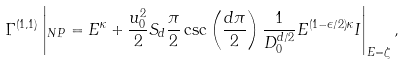Convert formula to latex. <formula><loc_0><loc_0><loc_500><loc_500>\Gamma ^ { ( 1 , 1 ) } \left | _ { N P } = E ^ { \kappa } + \frac { u _ { 0 } ^ { 2 } } { 2 } S _ { d } \frac { \pi } { 2 } \csc \left ( \frac { d \pi } { 2 } \right ) \frac { 1 } { D _ { 0 } ^ { d / 2 } } E ^ { ( 1 - \epsilon / 2 ) \kappa } I \right | _ { E = \zeta } ,</formula> 